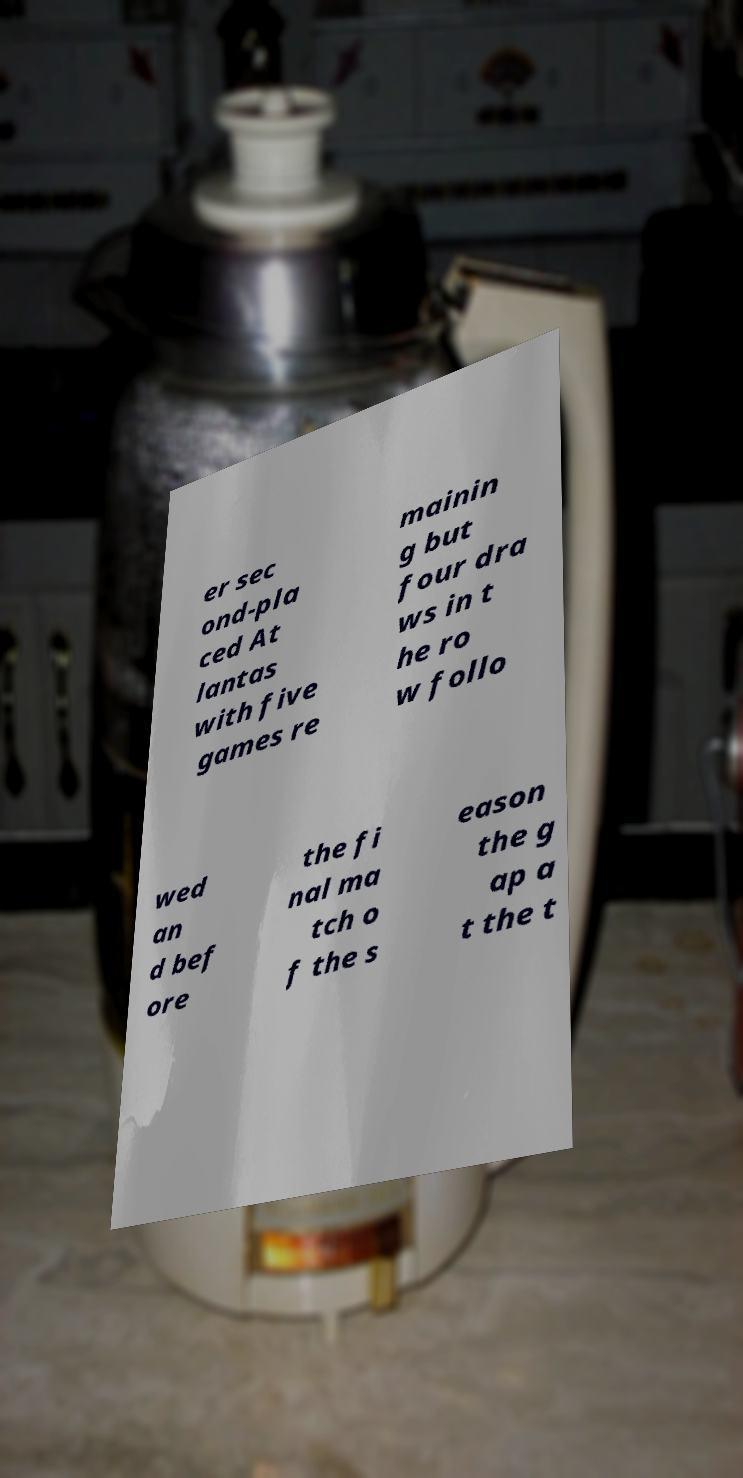What messages or text are displayed in this image? I need them in a readable, typed format. er sec ond-pla ced At lantas with five games re mainin g but four dra ws in t he ro w follo wed an d bef ore the fi nal ma tch o f the s eason the g ap a t the t 